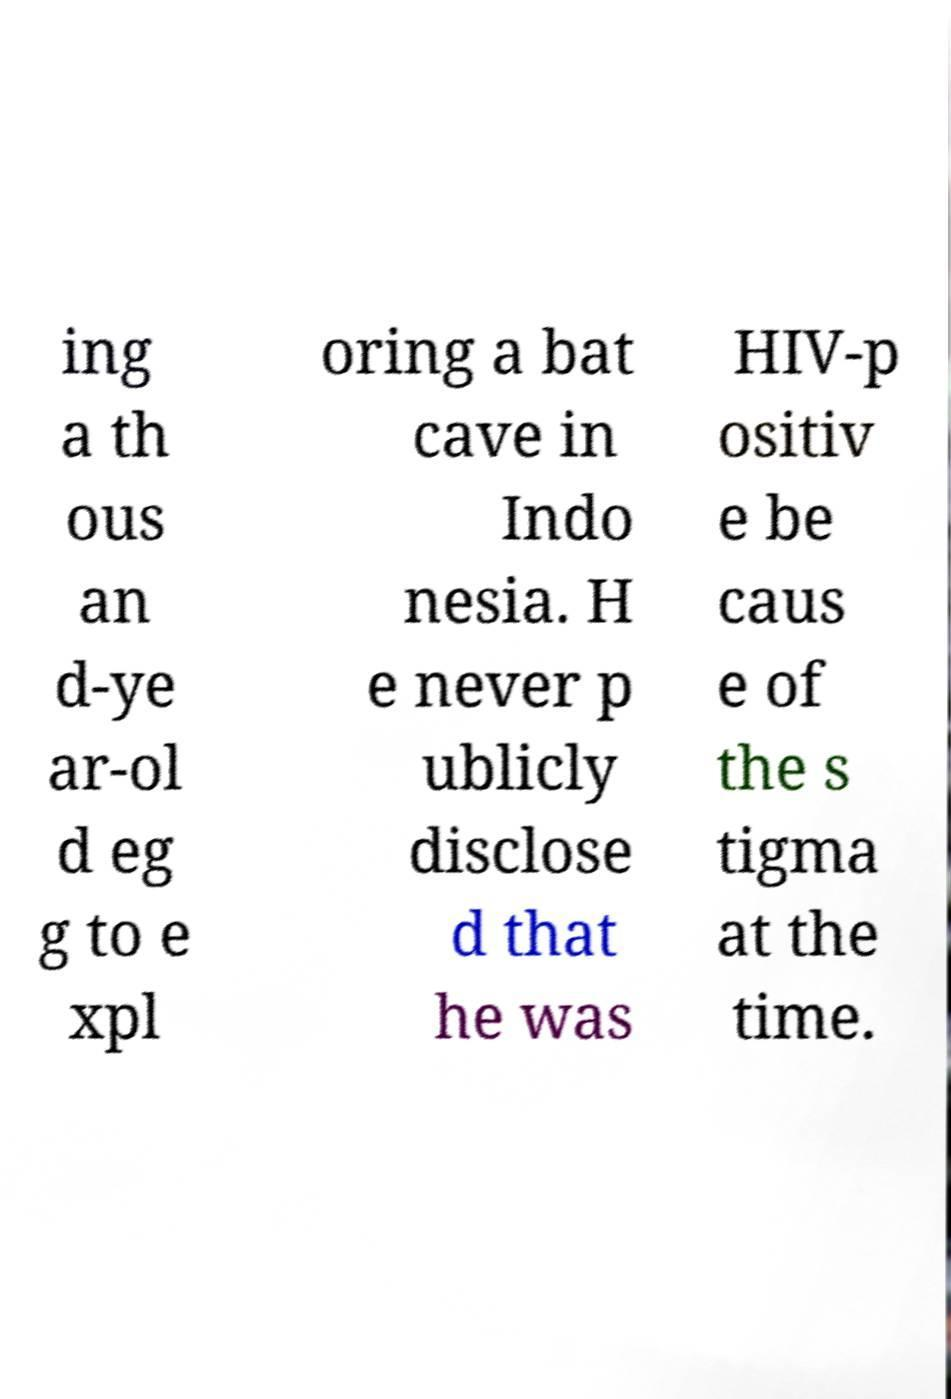Could you assist in decoding the text presented in this image and type it out clearly? ing a th ous an d-ye ar-ol d eg g to e xpl oring a bat cave in Indo nesia. H e never p ublicly disclose d that he was HIV-p ositiv e be caus e of the s tigma at the time. 